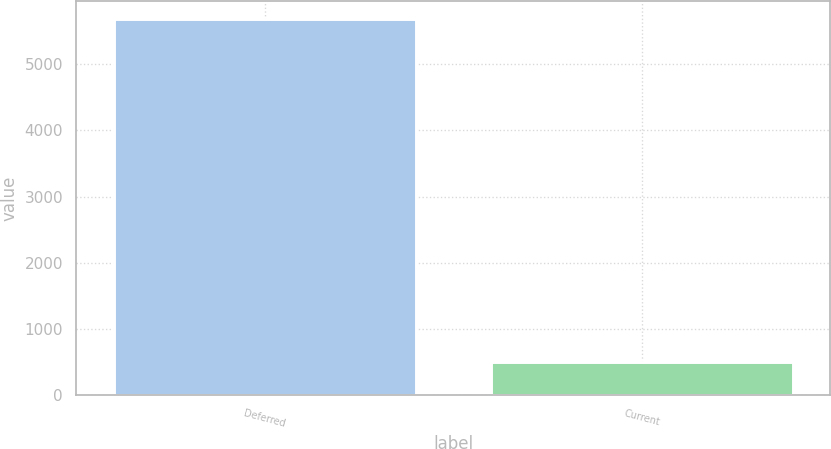<chart> <loc_0><loc_0><loc_500><loc_500><bar_chart><fcel>Deferred<fcel>Current<nl><fcel>5677<fcel>501<nl></chart> 